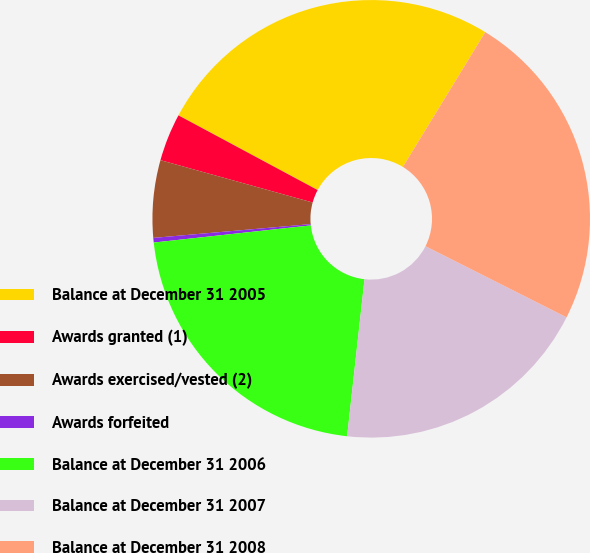Convert chart. <chart><loc_0><loc_0><loc_500><loc_500><pie_chart><fcel>Balance at December 31 2005<fcel>Awards granted (1)<fcel>Awards exercised/vested (2)<fcel>Awards forfeited<fcel>Balance at December 31 2006<fcel>Balance at December 31 2007<fcel>Balance at December 31 2008<nl><fcel>25.89%<fcel>3.52%<fcel>5.71%<fcel>0.34%<fcel>21.51%<fcel>19.32%<fcel>23.7%<nl></chart> 